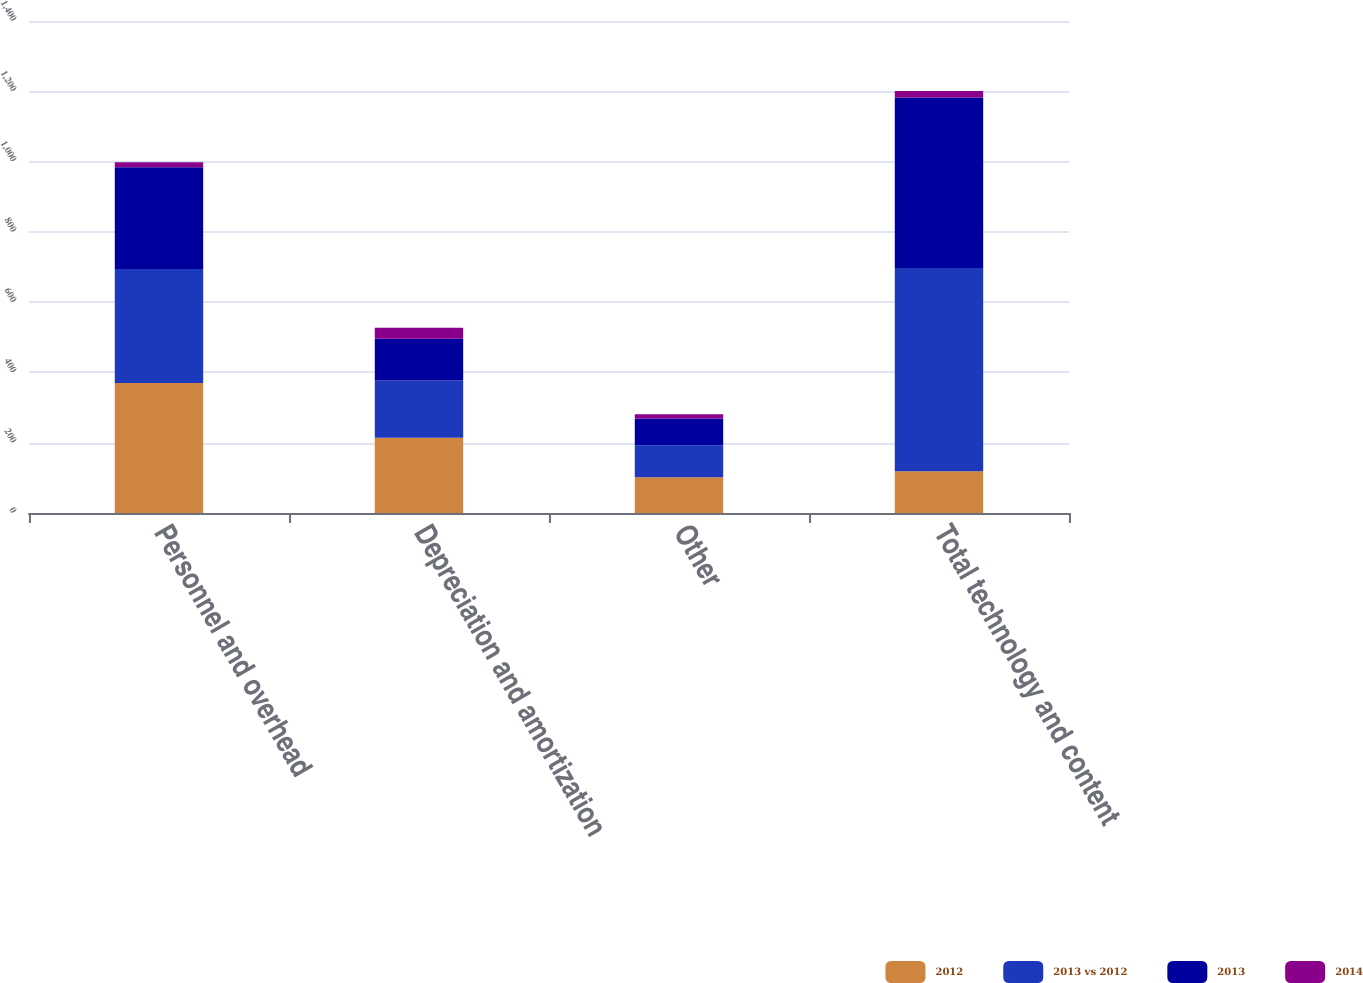Convert chart to OTSL. <chart><loc_0><loc_0><loc_500><loc_500><stacked_bar_chart><ecel><fcel>Personnel and overhead<fcel>Depreciation and amortization<fcel>Other<fcel>Total technology and content<nl><fcel>2012<fcel>370<fcel>214<fcel>102<fcel>119<nl><fcel>2013 vs 2012<fcel>324<fcel>163<fcel>91<fcel>578<nl><fcel>2013<fcel>290<fcel>119<fcel>76<fcel>485<nl><fcel>2014<fcel>14<fcel>31<fcel>12<fcel>19<nl></chart> 